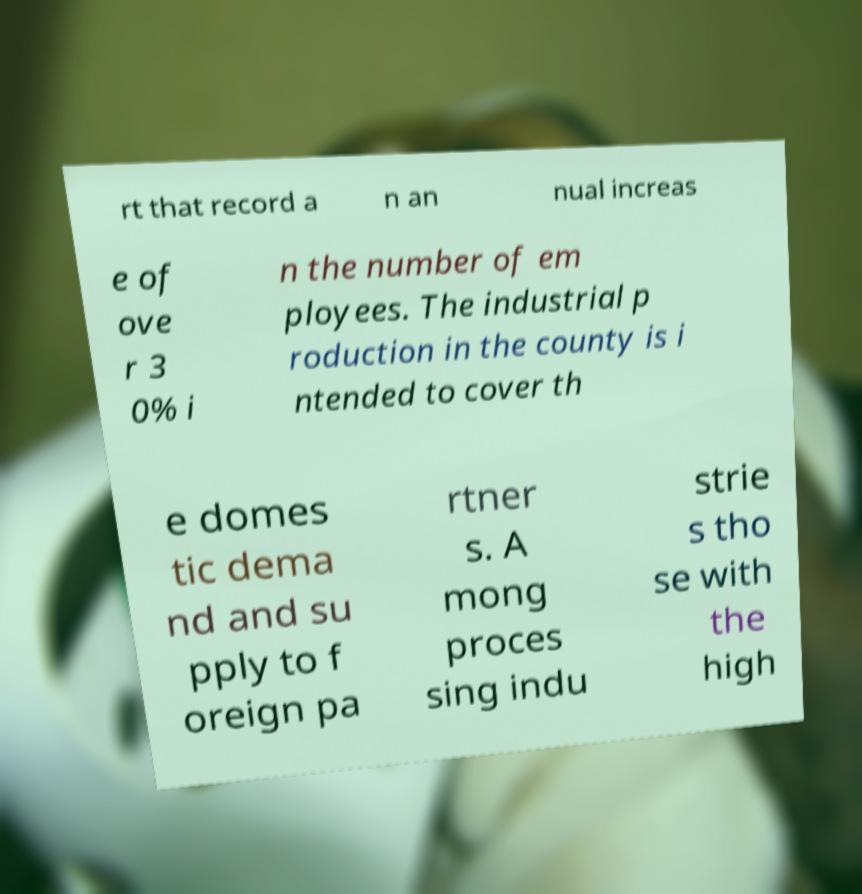Please identify and transcribe the text found in this image. rt that record a n an nual increas e of ove r 3 0% i n the number of em ployees. The industrial p roduction in the county is i ntended to cover th e domes tic dema nd and su pply to f oreign pa rtner s. A mong proces sing indu strie s tho se with the high 